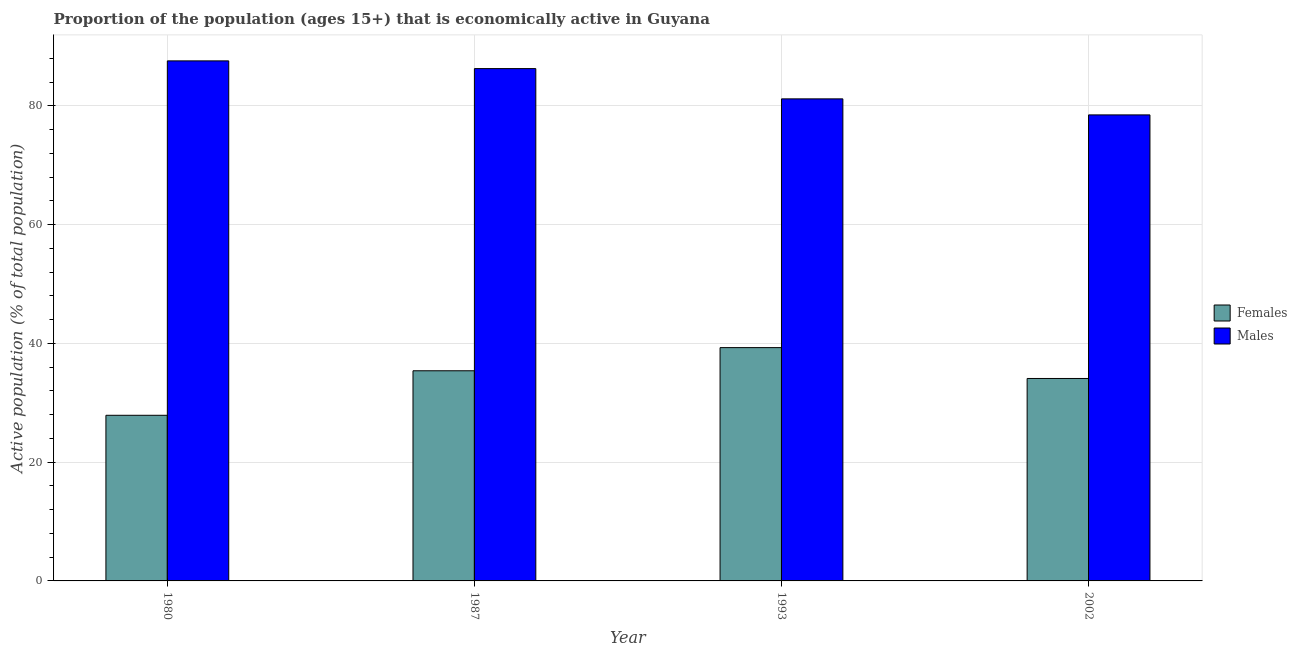What is the percentage of economically active male population in 1993?
Your answer should be compact. 81.2. Across all years, what is the maximum percentage of economically active male population?
Keep it short and to the point. 87.6. Across all years, what is the minimum percentage of economically active female population?
Your answer should be very brief. 27.9. In which year was the percentage of economically active male population maximum?
Provide a short and direct response. 1980. What is the total percentage of economically active female population in the graph?
Keep it short and to the point. 136.7. What is the difference between the percentage of economically active female population in 1987 and that in 1993?
Your response must be concise. -3.9. What is the difference between the percentage of economically active female population in 1987 and the percentage of economically active male population in 2002?
Make the answer very short. 1.3. What is the average percentage of economically active female population per year?
Your response must be concise. 34.17. In the year 1993, what is the difference between the percentage of economically active male population and percentage of economically active female population?
Provide a short and direct response. 0. What is the ratio of the percentage of economically active male population in 1987 to that in 2002?
Keep it short and to the point. 1.1. Is the difference between the percentage of economically active male population in 1987 and 2002 greater than the difference between the percentage of economically active female population in 1987 and 2002?
Provide a succinct answer. No. What is the difference between the highest and the second highest percentage of economically active male population?
Make the answer very short. 1.3. What is the difference between the highest and the lowest percentage of economically active male population?
Give a very brief answer. 9.1. Is the sum of the percentage of economically active male population in 1993 and 2002 greater than the maximum percentage of economically active female population across all years?
Your answer should be very brief. Yes. What does the 1st bar from the left in 1980 represents?
Keep it short and to the point. Females. What does the 1st bar from the right in 1993 represents?
Your answer should be very brief. Males. How many bars are there?
Your response must be concise. 8. Are all the bars in the graph horizontal?
Your answer should be compact. No. Does the graph contain grids?
Make the answer very short. Yes. Where does the legend appear in the graph?
Your response must be concise. Center right. How many legend labels are there?
Provide a succinct answer. 2. What is the title of the graph?
Provide a succinct answer. Proportion of the population (ages 15+) that is economically active in Guyana. Does "Research and Development" appear as one of the legend labels in the graph?
Your response must be concise. No. What is the label or title of the X-axis?
Give a very brief answer. Year. What is the label or title of the Y-axis?
Keep it short and to the point. Active population (% of total population). What is the Active population (% of total population) of Females in 1980?
Your answer should be compact. 27.9. What is the Active population (% of total population) in Males in 1980?
Provide a short and direct response. 87.6. What is the Active population (% of total population) of Females in 1987?
Ensure brevity in your answer.  35.4. What is the Active population (% of total population) in Males in 1987?
Offer a very short reply. 86.3. What is the Active population (% of total population) in Females in 1993?
Give a very brief answer. 39.3. What is the Active population (% of total population) in Males in 1993?
Your response must be concise. 81.2. What is the Active population (% of total population) of Females in 2002?
Keep it short and to the point. 34.1. What is the Active population (% of total population) of Males in 2002?
Your answer should be very brief. 78.5. Across all years, what is the maximum Active population (% of total population) of Females?
Offer a terse response. 39.3. Across all years, what is the maximum Active population (% of total population) of Males?
Give a very brief answer. 87.6. Across all years, what is the minimum Active population (% of total population) in Females?
Provide a succinct answer. 27.9. Across all years, what is the minimum Active population (% of total population) in Males?
Make the answer very short. 78.5. What is the total Active population (% of total population) in Females in the graph?
Keep it short and to the point. 136.7. What is the total Active population (% of total population) in Males in the graph?
Your answer should be compact. 333.6. What is the difference between the Active population (% of total population) of Males in 1980 and that in 1987?
Offer a terse response. 1.3. What is the difference between the Active population (% of total population) in Females in 1993 and that in 2002?
Give a very brief answer. 5.2. What is the difference between the Active population (% of total population) of Females in 1980 and the Active population (% of total population) of Males in 1987?
Keep it short and to the point. -58.4. What is the difference between the Active population (% of total population) of Females in 1980 and the Active population (% of total population) of Males in 1993?
Your answer should be compact. -53.3. What is the difference between the Active population (% of total population) in Females in 1980 and the Active population (% of total population) in Males in 2002?
Give a very brief answer. -50.6. What is the difference between the Active population (% of total population) in Females in 1987 and the Active population (% of total population) in Males in 1993?
Your answer should be very brief. -45.8. What is the difference between the Active population (% of total population) in Females in 1987 and the Active population (% of total population) in Males in 2002?
Make the answer very short. -43.1. What is the difference between the Active population (% of total population) in Females in 1993 and the Active population (% of total population) in Males in 2002?
Give a very brief answer. -39.2. What is the average Active population (% of total population) in Females per year?
Your response must be concise. 34.17. What is the average Active population (% of total population) of Males per year?
Your answer should be compact. 83.4. In the year 1980, what is the difference between the Active population (% of total population) of Females and Active population (% of total population) of Males?
Your response must be concise. -59.7. In the year 1987, what is the difference between the Active population (% of total population) in Females and Active population (% of total population) in Males?
Ensure brevity in your answer.  -50.9. In the year 1993, what is the difference between the Active population (% of total population) in Females and Active population (% of total population) in Males?
Provide a succinct answer. -41.9. In the year 2002, what is the difference between the Active population (% of total population) of Females and Active population (% of total population) of Males?
Offer a very short reply. -44.4. What is the ratio of the Active population (% of total population) of Females in 1980 to that in 1987?
Keep it short and to the point. 0.79. What is the ratio of the Active population (% of total population) of Males in 1980 to that in 1987?
Your answer should be compact. 1.02. What is the ratio of the Active population (% of total population) in Females in 1980 to that in 1993?
Your response must be concise. 0.71. What is the ratio of the Active population (% of total population) of Males in 1980 to that in 1993?
Make the answer very short. 1.08. What is the ratio of the Active population (% of total population) in Females in 1980 to that in 2002?
Your answer should be compact. 0.82. What is the ratio of the Active population (% of total population) in Males in 1980 to that in 2002?
Make the answer very short. 1.12. What is the ratio of the Active population (% of total population) of Females in 1987 to that in 1993?
Offer a terse response. 0.9. What is the ratio of the Active population (% of total population) of Males in 1987 to that in 1993?
Make the answer very short. 1.06. What is the ratio of the Active population (% of total population) in Females in 1987 to that in 2002?
Provide a succinct answer. 1.04. What is the ratio of the Active population (% of total population) in Males in 1987 to that in 2002?
Give a very brief answer. 1.1. What is the ratio of the Active population (% of total population) of Females in 1993 to that in 2002?
Give a very brief answer. 1.15. What is the ratio of the Active population (% of total population) of Males in 1993 to that in 2002?
Provide a succinct answer. 1.03. What is the difference between the highest and the second highest Active population (% of total population) in Males?
Provide a short and direct response. 1.3. What is the difference between the highest and the lowest Active population (% of total population) of Females?
Keep it short and to the point. 11.4. 